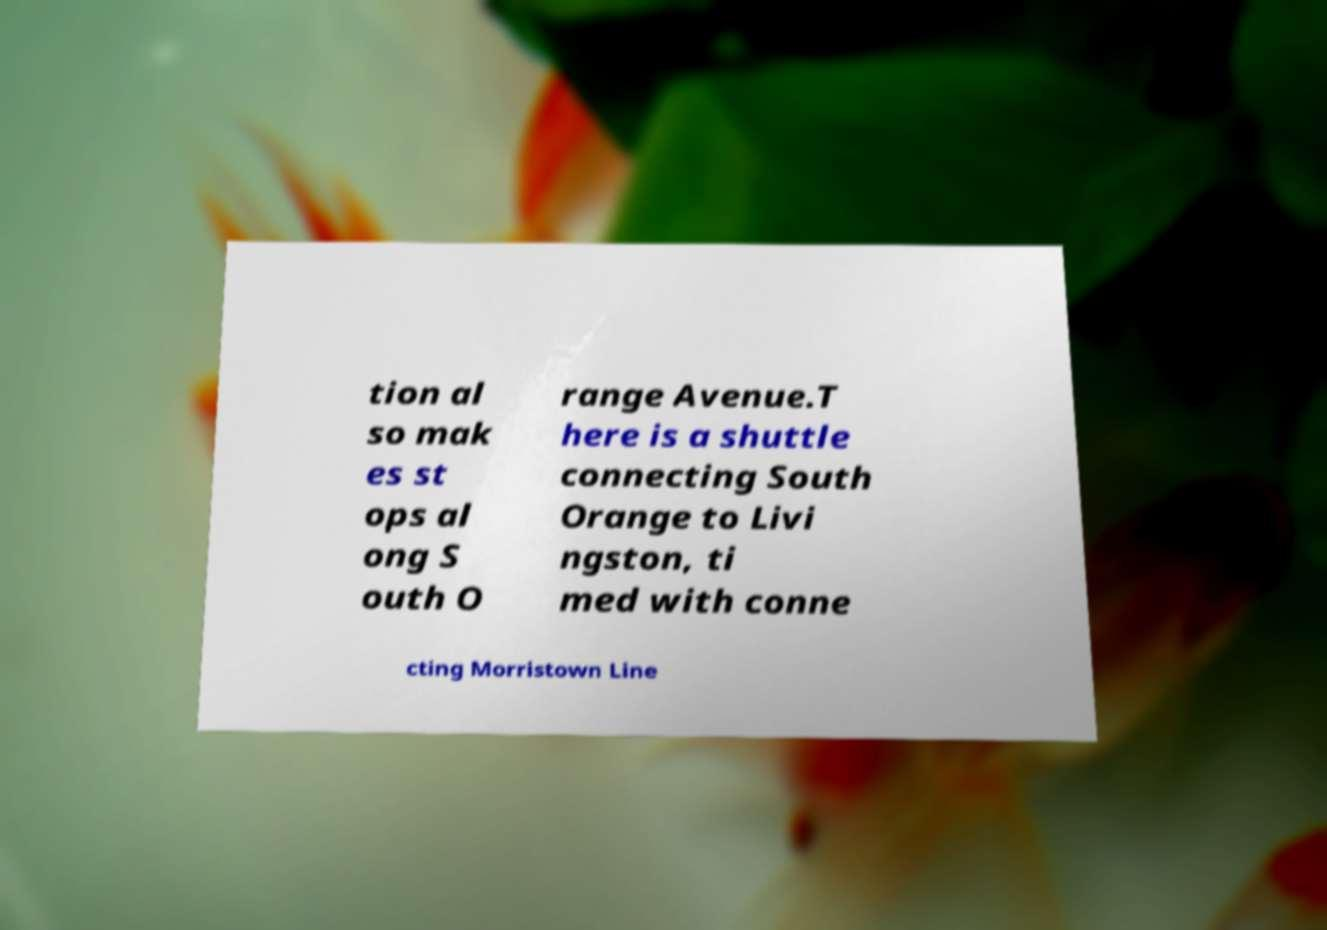Can you read and provide the text displayed in the image?This photo seems to have some interesting text. Can you extract and type it out for me? tion al so mak es st ops al ong S outh O range Avenue.T here is a shuttle connecting South Orange to Livi ngston, ti med with conne cting Morristown Line 